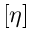Convert formula to latex. <formula><loc_0><loc_0><loc_500><loc_500>\left [ \eta \right ]</formula> 